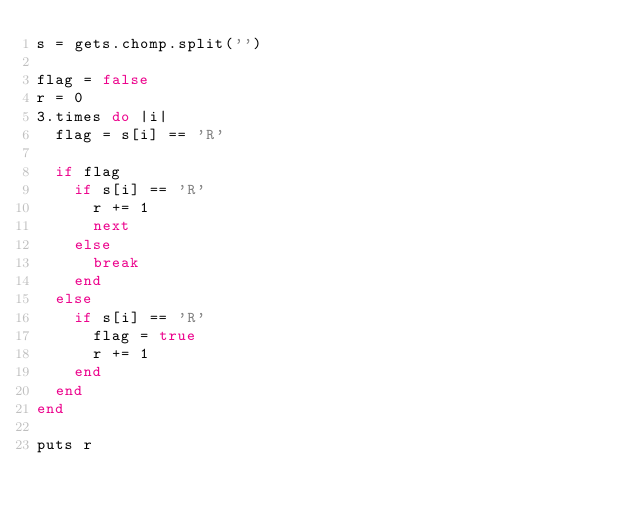Convert code to text. <code><loc_0><loc_0><loc_500><loc_500><_Ruby_>s = gets.chomp.split('')

flag = false
r = 0
3.times do |i|
  flag = s[i] == 'R'

  if flag
    if s[i] == 'R'
      r += 1
      next
    else
      break
    end
  else
    if s[i] == 'R'
      flag = true
      r += 1
    end
  end
end

puts r
</code> 